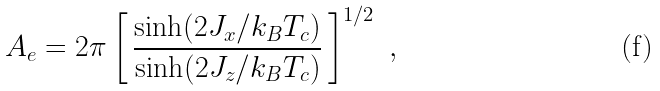<formula> <loc_0><loc_0><loc_500><loc_500>A _ { e } = 2 \pi \left [ \, \frac { \sinh ( 2 J _ { x } / k _ { B } T _ { c } ) } { \sinh ( 2 J _ { z } / k _ { B } T _ { c } ) } \, \right ] ^ { 1 / 2 } \ ,</formula> 